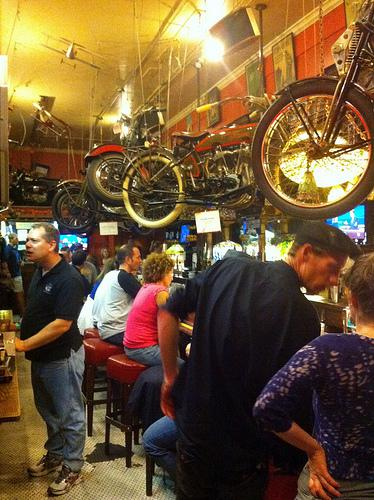Question: where was this photo taken?
Choices:
A. A restaurant.
B. A bar.
C. At home.
D. A wedding.
Answer with the letter. Answer: B Question: what are these people doing?
Choices:
A. Eating.
B. Laughing.
C. Drinking.
D. Crying.
Answer with the letter. Answer: C Question: what day of the week is it?
Choices:
A. Tuesday.
B. Monday.
C. Wednesday.
D. Sunday.
Answer with the letter. Answer: B Question: what time is it?
Choices:
A. Midnight.
B. 10am.
C. 6pm.
D. Noon.
Answer with the letter. Answer: D 